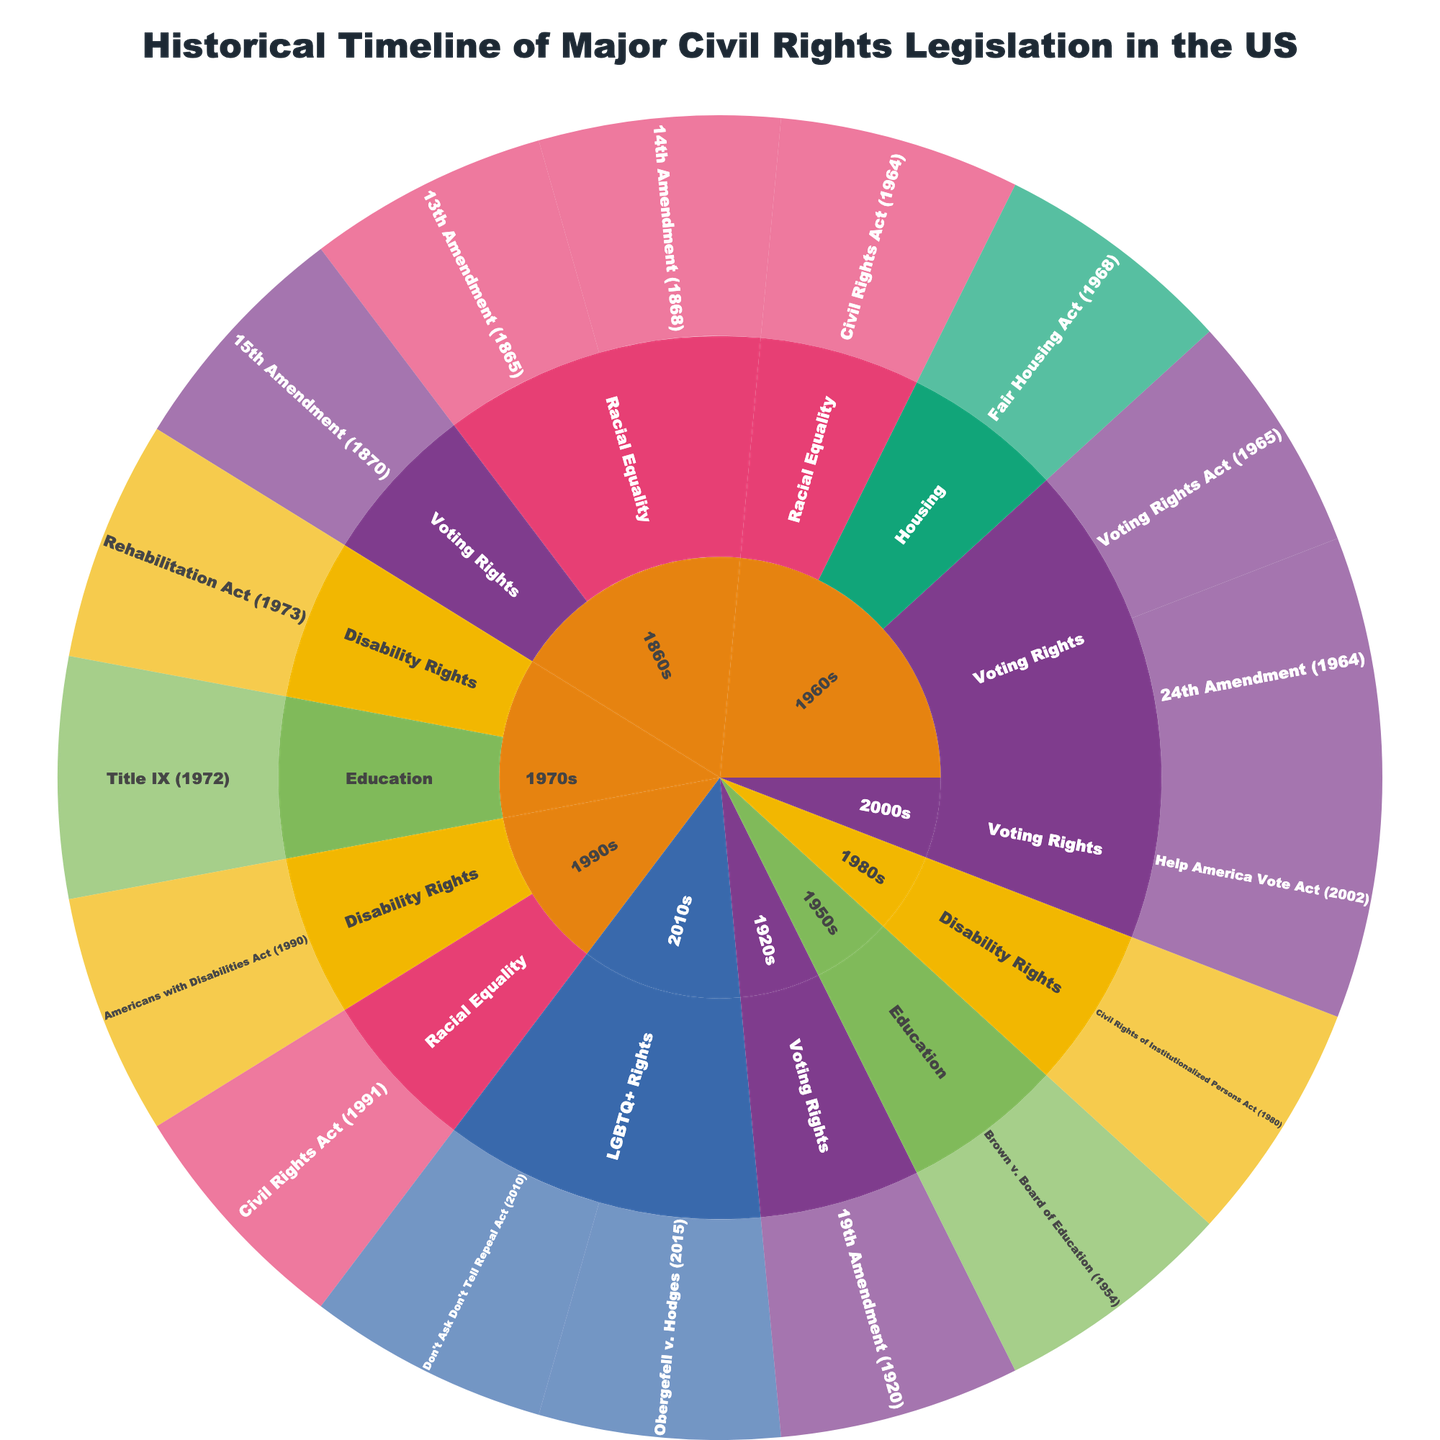What is the title of the figure? The title of a figure is usually displayed at the top and serves as a summary of the content. In this figure, the title is "Historical Timeline of Major Civil Rights Legislation in the US".
Answer: Historical Timeline of Major Civil Rights Legislation in the US How many decades are represented in the plot? The plot is organized by different time periods represented as "Decade". By counting these periods, we find the decades to be the 1860s, 1920s, 1950s, 1960s, 1970s, 1980s, 1990s, 2000s, and 2010s.
Answer: 9 Which legislation is categorized under "Housing" and in which decade? To find this, we look under the "Category" label in the plot for "Housing" and check the decade it falls under along with the specific legislation. The Fair Housing Act (1968) is listed under the 1960s.
Answer: Fair Housing Act (1968), 1960s Which category has the highest number of legislations in the 1960s? We examine the sunburst plot for the 1960s and count the number of legislations under each category. The categories and their counts are: Voting Rights (3), Racial Equality (1), Housing (1). Voting Rights has the highest count.
Answer: Voting Rights How many legislations related to "Disability Rights" are represented in the figure? We look for the "Disability Rights" category and count the number of legislations present in this section of the sunburst plot. The legislations are: Rehabilitation Act (1973), Civil Rights of Institutionalized Persons Act (1980), and Americans with Disabilities Act (1990). Thus, there are 3.
Answer: 3 Which decade introduced the Civil Rights Act twice, and what years were they? By locating the different instances of "Civil Rights Act" in the sunburst plot and identifying their associated decades and years, we see that the 1960s and 1990s introduced the acts in 1964 and 1991, respectively.
Answer: 1960s (1964) and 1990s (1991) What is the only legislation in the 1950s and which category does it belong to? To find this information, we look for the section of the sunburst plot under the 1950s decade and identify the sole piece of legislation and its category. It is Brown v. Board of Education (1954) under "Education".
Answer: Brown v. Board of Education (1954), Education Which categories have legislation passed in more than one decade? By examining the unique categories within each decade, we can find that "Racial Equality", "Voting Rights", "Disability Rights", and "Voting Rights" appear in more than one decade.
Answer: Racial Equality, Voting Rights, Disability Rights Compare the total number of legislations in the 1920s and 2010s. Which decade has more legislations? Count the legislations under the 1920s and 2010s sections of the sunburst plot. The 1920s have one legislation, and the 2010s have two. Hence, the 2010s have more legislations.
Answer: 2010s Which category first appears in the 1970s and what are the legislations under it? From the sunburst plot, identify which categories make their initial appearance in the 1970s and list the legislations under those categories. "Disability Rights" first appears with the Rehabilitation Act (1973).
Answer: Disability Rights, Rehabilitation Act (1973) 